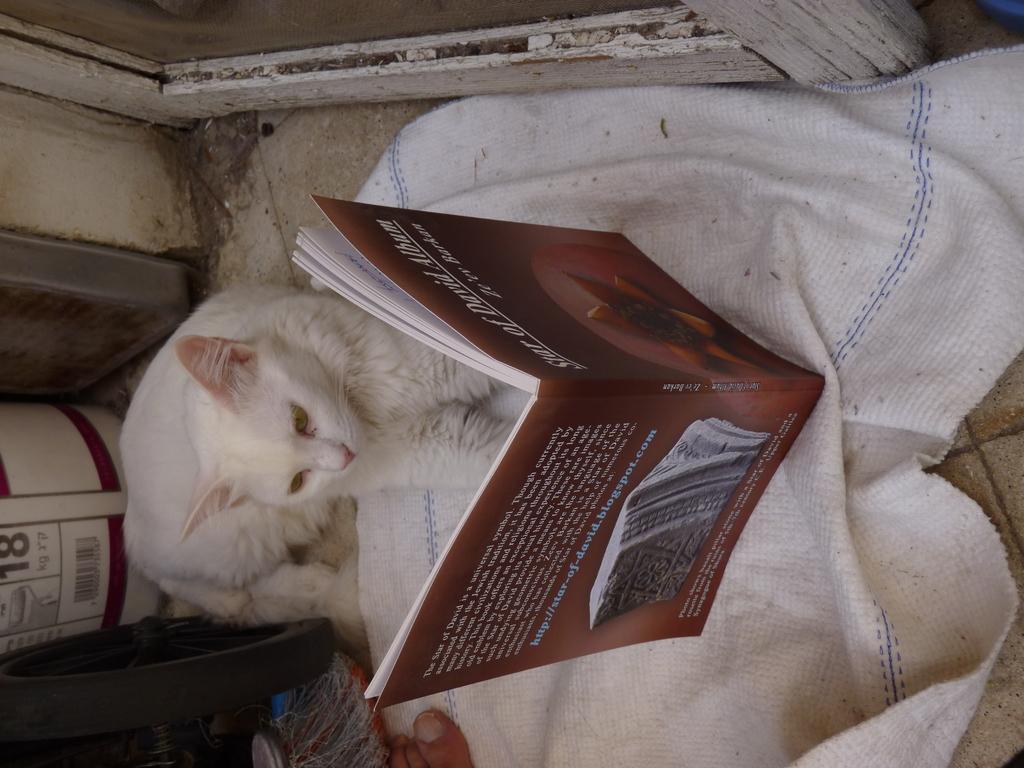Could you give a brief overview of what you see in this image? As we can see in the image on the ground there is a cloth on which a book is kept and in front of it there is a cat who is looking at the book and at the back there is a box in white colour. 